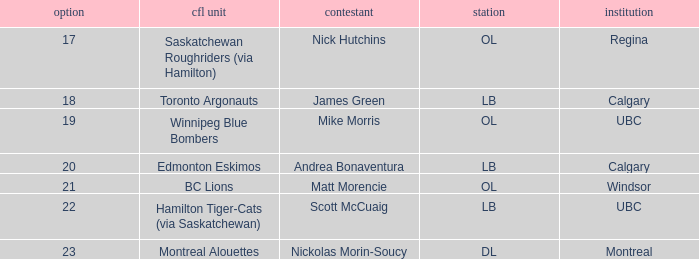Which player is on the BC Lions?  Matt Morencie. 